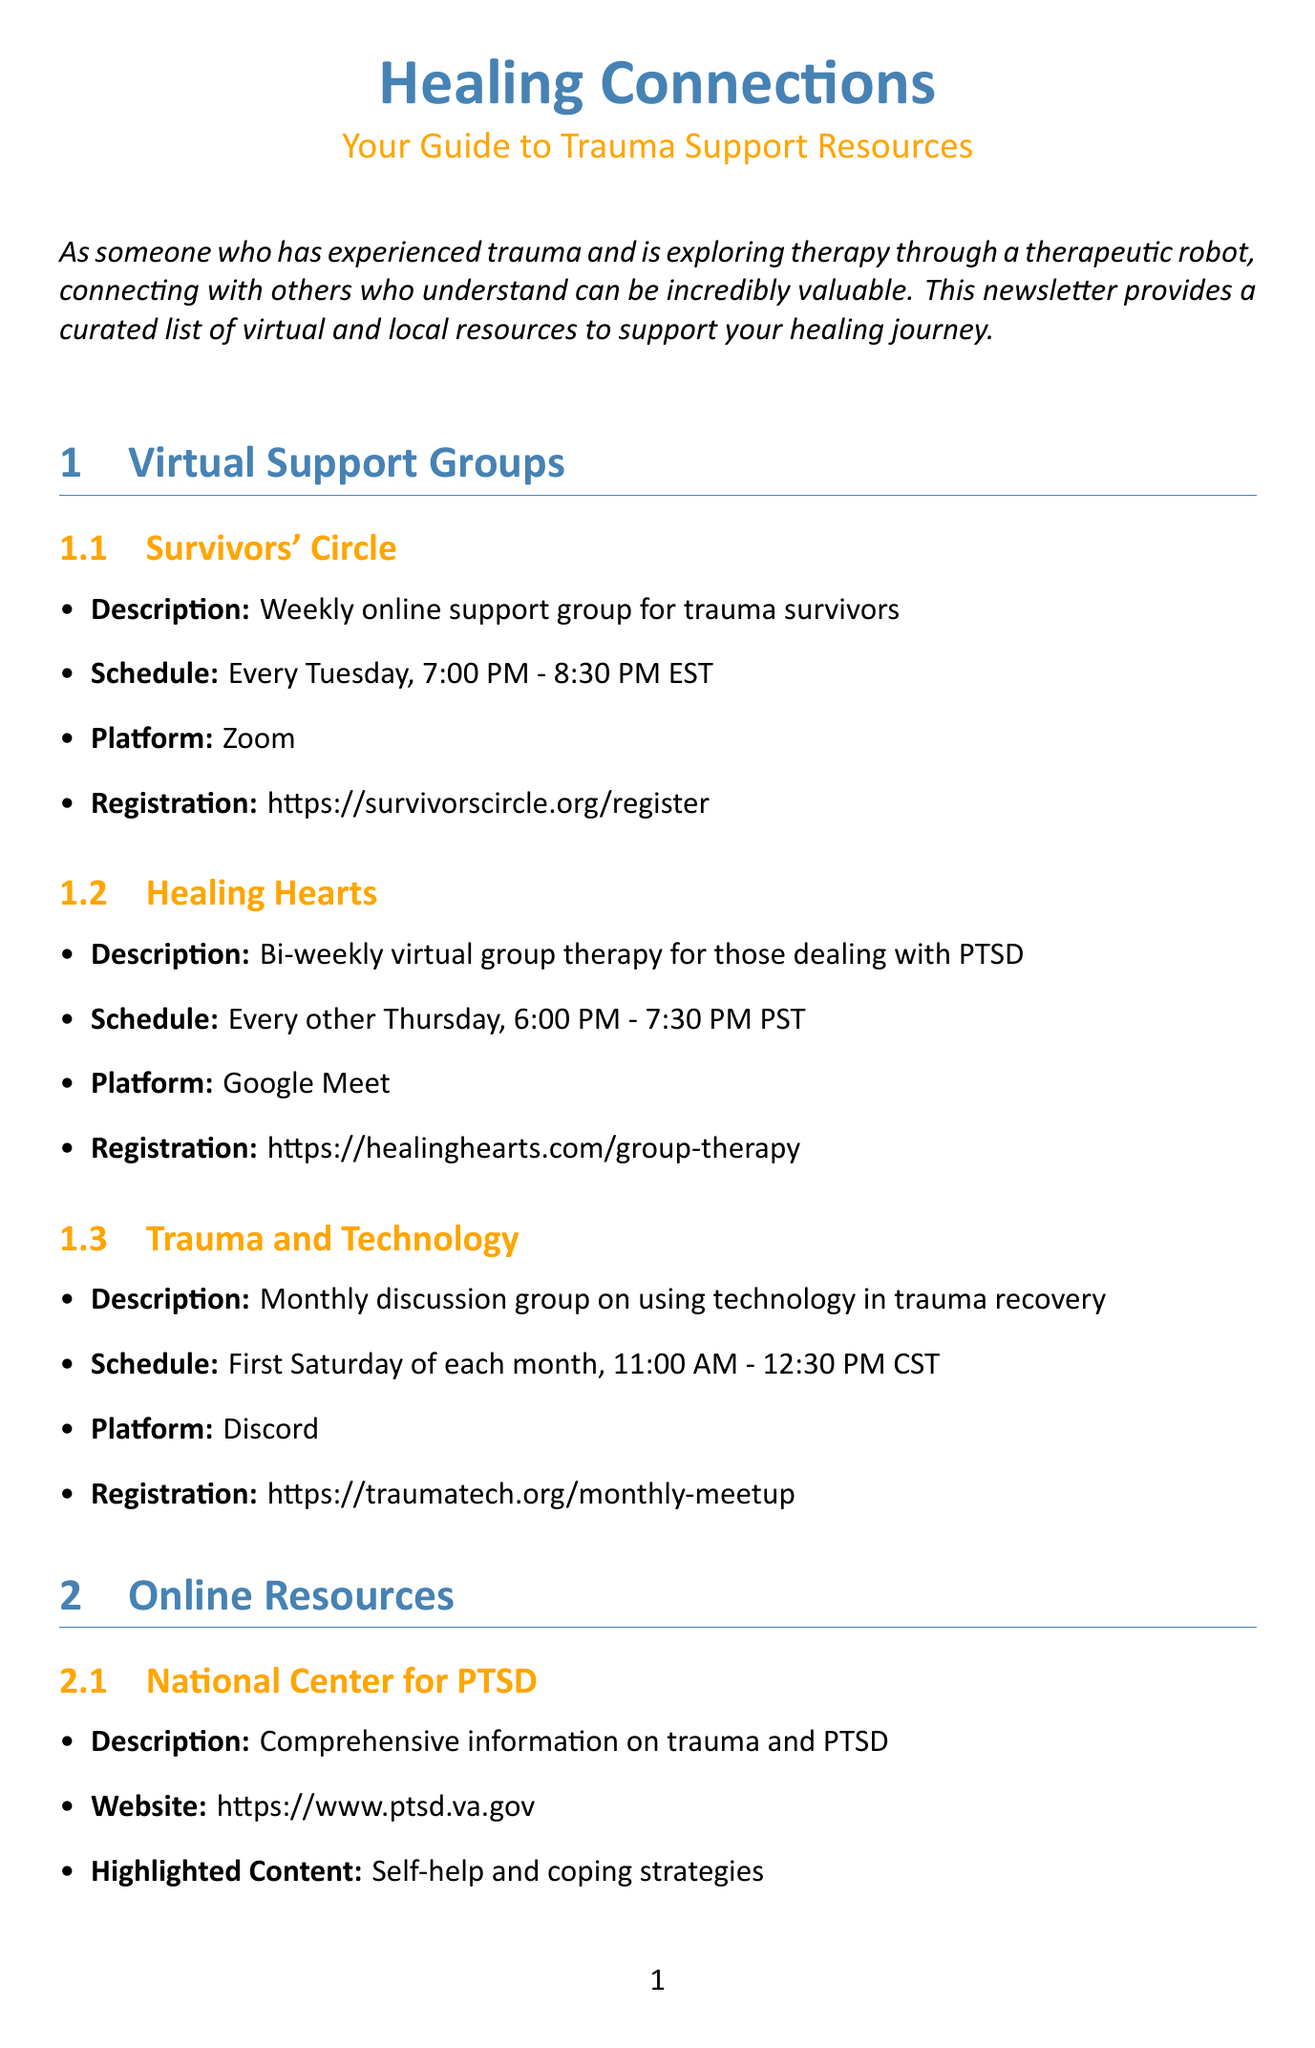what is the title of the newsletter? The title is prominently displayed at the top of the document, highlighting the focus on healing connections and trauma support resources.
Answer: Healing Connections: Your Guide to Trauma Support Resources when does the "Survivors' Circle" group meet? The document specifies the schedule for this support group, indicating it occurs weekly on a specific day and time.
Answer: Every Tuesday, 7:00 PM - 8:30 PM EST what online platform is used for "Healing Hearts"? The document notes the platform for each virtual group, which is crucial for attendees to know where to join.
Answer: Google Meet how often does the "Trauma-Informed Yoga Class" occur? The frequency of this class is clearly mentioned in the local events section, illustrating its regularity.
Answer: Every Monday what is the registration requirement for the "Mindfulness in Nature Walk"? The document indicates whether registration is necessary for attending specific local events, which is important for planning.
Answer: Not required what type of support does the "National Center for PTSD" provide? The description of this online resource gives insight into the kind of information one can expect to find there.
Answer: Comprehensive information on trauma and PTSD which local event focuses on creative expression? The name of the local event is mentioned in the document, highlighting its theme and purpose.
Answer: Trauma and Art Therapy Workshop what is a highlighted content from the "Calm App"? The document lists specific highlighted content for each resource, showcasing useful features available to users.
Answer: Guided meditations for managing trauma triggers what type of yoga is offered in the "Trauma-Informed Yoga Class"? Understanding the nature of the yoga class helps in identifying its compatibility with attendees seeking trauma-specific practices.
Answer: Gentle yoga practice designed for trauma survivors 